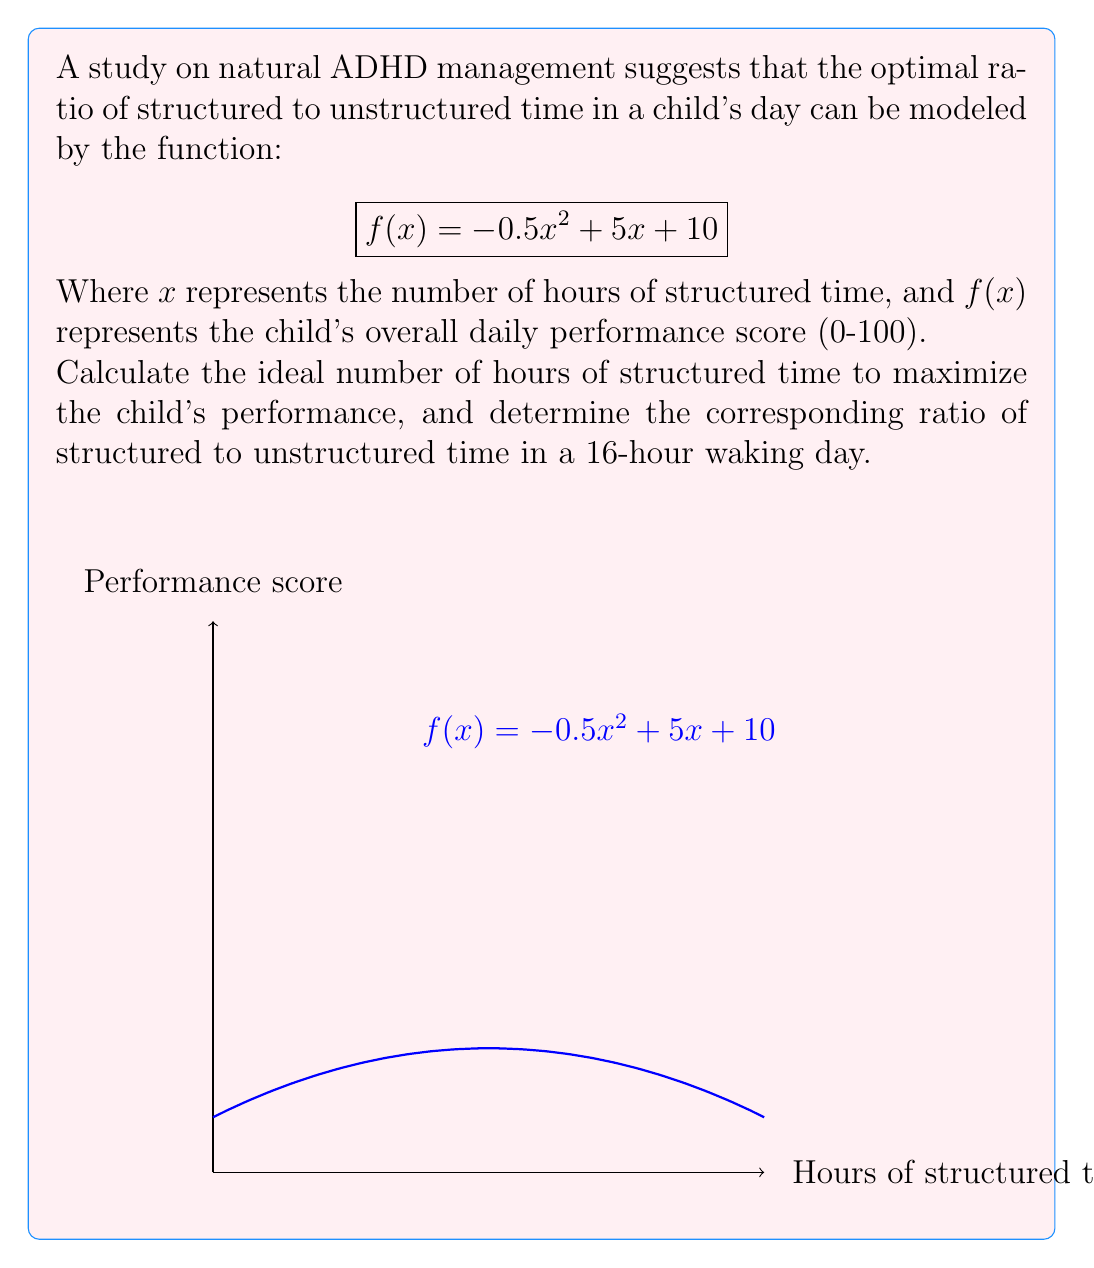Show me your answer to this math problem. To solve this optimization problem, we'll follow these steps:

1) Find the maximum of the function $f(x) = -0.5x^2 + 5x + 10$:
   
   The maximum occurs where $f'(x) = 0$
   
   $f'(x) = -x + 5$
   
   Set $f'(x) = 0$:
   $-x + 5 = 0$
   $x = 5$

2) Verify it's a maximum (not a minimum):
   
   $f''(x) = -1 < 0$, confirming it's a maximum

3) Calculate the ideal number of structured hours:
   
   $x = 5$ hours

4) Calculate the ratio of structured to unstructured time:
   
   Structured time: 5 hours
   Unstructured time: 16 - 5 = 11 hours
   Ratio: $5:11$ or simplified to $5:11$

5) Express the ratio as a fraction:
   
   $\frac{5}{16}$ structured time to $\frac{11}{16}$ unstructured time

Therefore, the ideal ratio is $5:11$ or $\frac{5}{16}$ structured time to $\frac{11}{16}$ unstructured time.
Answer: 5 hours structured time; ratio $5:11$ or $\frac{5}{16}:\frac{11}{16}$ 